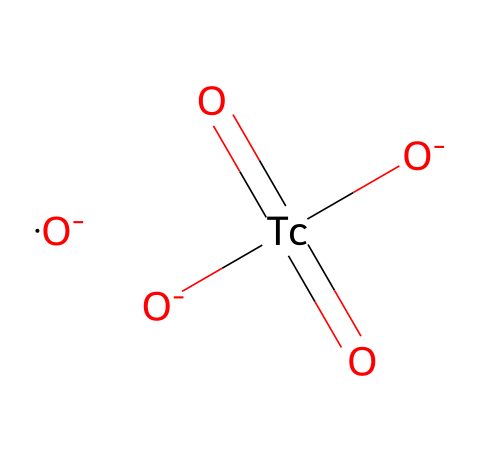What is the main metal in this chemical structure? The SMILES representation includes 'Tc', which refers to technetium, identifying it as the main metal in the chemical structure.
Answer: technetium How many oxygen atoms are present in the structure? By analyzing the SMILES, there are four 'O' elements, indicating that there are four oxygen atoms present in the chemical structure.
Answer: four What type of bonds are formed between the technetium and oxygen atoms? The structure shows '=' between Tc and O, indicating double bonds between technetium and the oxygen atoms. This indicates that they are covalently bonded with higher electron sharing.
Answer: double What overall charge does this chemical species have? The representation includes '[O-]' indicating that two oxygen atoms carry a negative charge, which balances the ionization of Tc due to its isotopic nature, leading to an overall charge of -2.
Answer: -2 Is this isotope used for diagnostic imaging? Technetium-99m is well-known in the medical field as a radioisotope used in various imaging techniques, confirming its utilization in medical diagnostics.
Answer: yes What distinctive feature of technetium-99m makes it suitable for medical imaging? Technetium-99m releases gamma rays during decay, which can be detected during imaging, making it a highly suitable isotope for medical diagnostic purposes.
Answer: gamma rays 